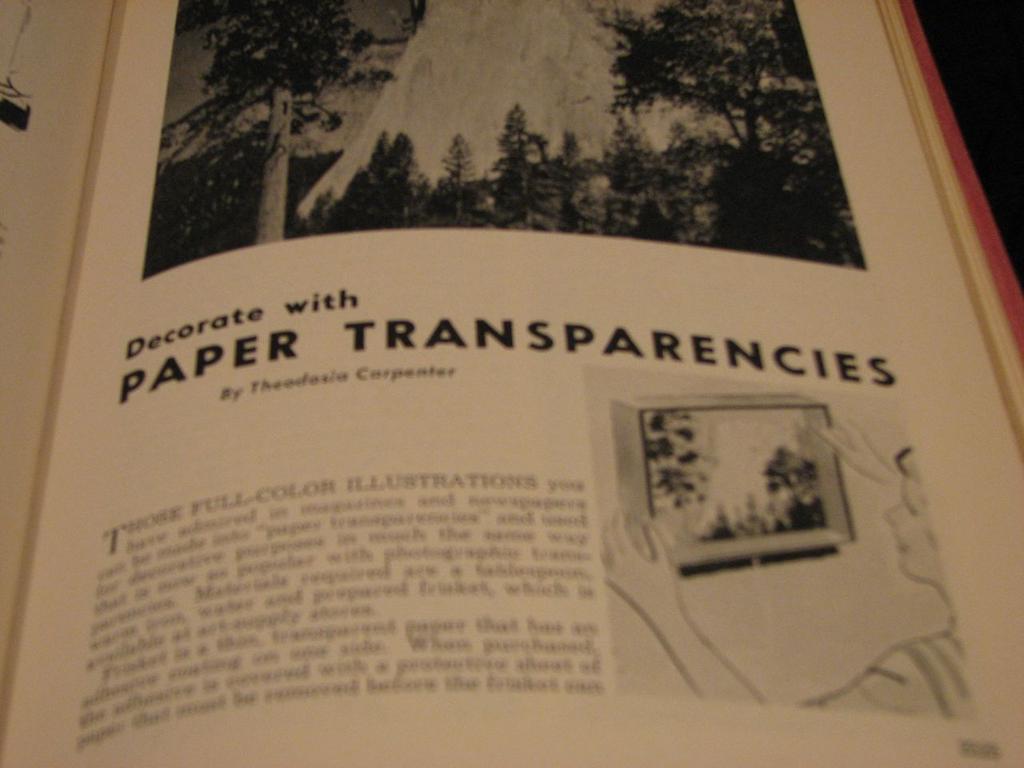What can you decorate with?
Offer a terse response. Paper transparencies. Who wrote this book?
Make the answer very short. Theodoria carpenter. 